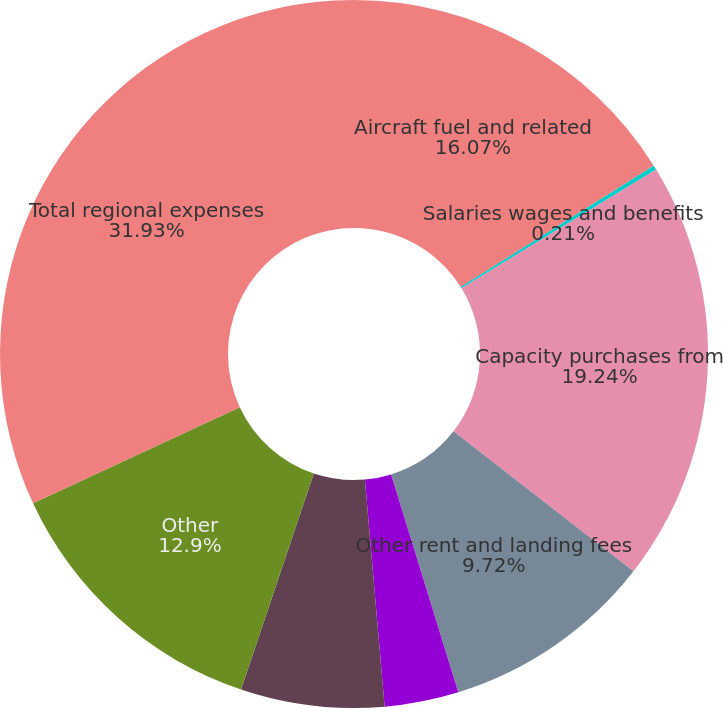Convert chart. <chart><loc_0><loc_0><loc_500><loc_500><pie_chart><fcel>Aircraft fuel and related<fcel>Salaries wages and benefits<fcel>Capacity purchases from<fcel>Other rent and landing fees<fcel>Selling expenses<fcel>Depreciation and amortization<fcel>Other<fcel>Total regional expenses<nl><fcel>16.07%<fcel>0.21%<fcel>19.24%<fcel>9.72%<fcel>3.38%<fcel>6.55%<fcel>12.9%<fcel>31.93%<nl></chart> 